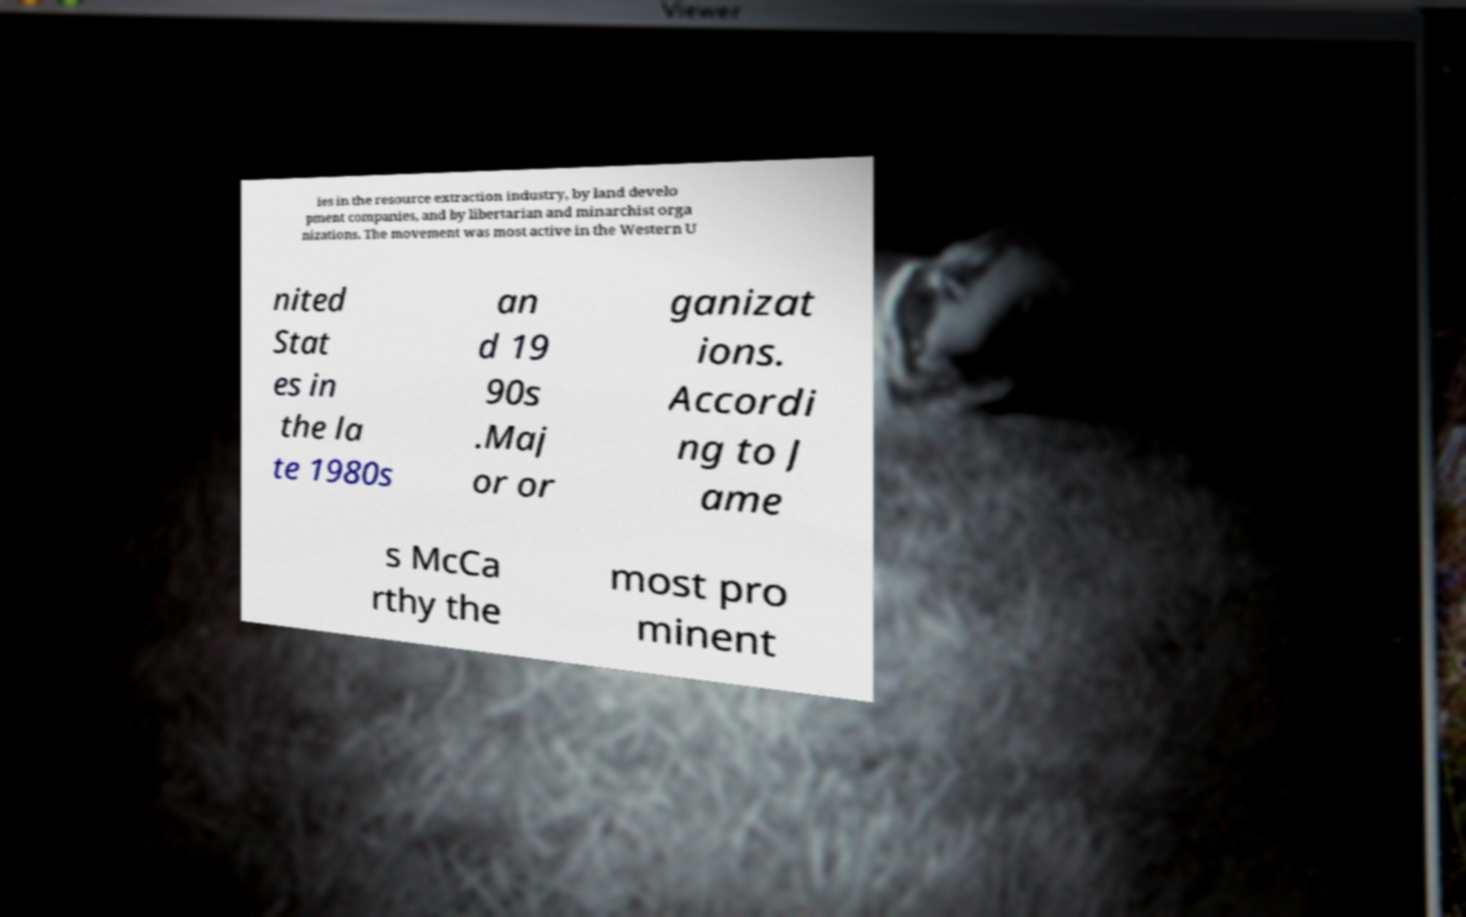Can you accurately transcribe the text from the provided image for me? ies in the resource extraction industry, by land develo pment companies, and by libertarian and minarchist orga nizations. The movement was most active in the Western U nited Stat es in the la te 1980s an d 19 90s .Maj or or ganizat ions. Accordi ng to J ame s McCa rthy the most pro minent 